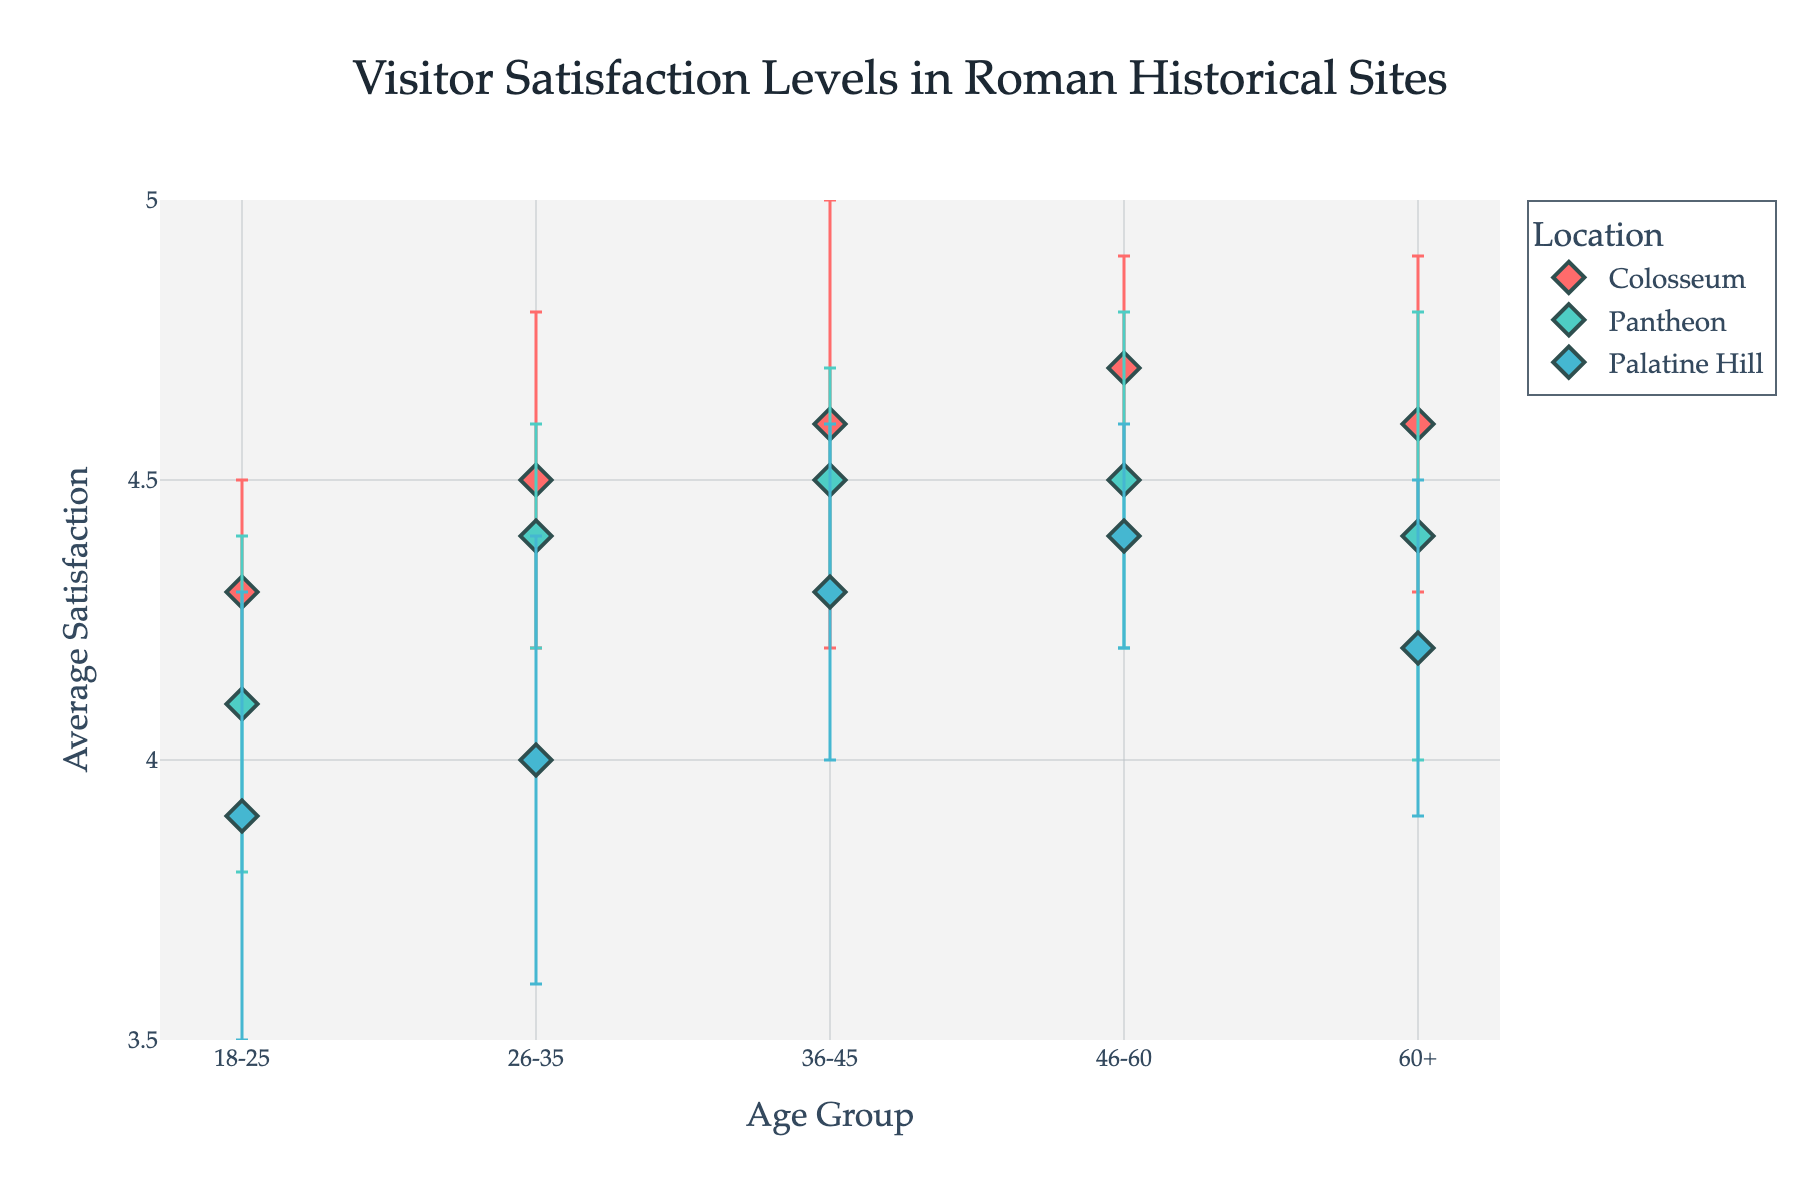What is the title of the plot? The title is displayed at the top of the plot, indicating the main subject of the visualized data. In this plot, the title is "Visitor Satisfaction Levels in Roman Historical Sites".
Answer: Visitor Satisfaction Levels in Roman Historical Sites What are the average satisfaction levels for the Colosseum among the 18-25 age group? Look for the marker representing the Colosseum for the 18-25 age group on the plot. The average satisfaction level is indicated by the position of the dot along the vertical axis.
Answer: 4.3 Which historical site has the highest average satisfaction level for the 46-60 age group? Compare the positions of the dots for the 46-60 age group across different historical sites. The highest position along the vertical axis indicates the highest average satisfaction level.
Answer: Colosseum What is the difference in average satisfaction level between the age groups 26-35 and 60+ for the Pantheon? Find the average satisfaction levels for the Pantheon in both the 26-35 and 60+ age groups. The values are 4.4 and 4.4 respectively. Subtract the smaller value from the larger one.
Answer: 0 Which age group shows the smallest error for the Palatine Hill site? Look for error bars attached to the dots representing the Palatine Hill site for different age groups. The smallest error is indicated by the shortest error bar.
Answer: 46-60 How does the average satisfaction level for the Colosseum compare between the age group 18-25 and 36-45? Check the average satisfaction values for the Colosseum in both age groups: 4.3 for 18-25 and 4.6 for 36-45. The 36-45 age group has a higher satisfaction level.
Answer: Higher for 36-45 What is the range of the y-axis in the plot? The y-axis range can be identified by examining the lowest and highest values marked on the y-axis scale. In this plot, it ranges from 3.5 to 5.
Answer: 3.5 to 5 If we consider the error bars, which location within the 36-45 age group has the largest possible satisfaction range? For the 36-45 age group, compare the lengths of the error bars for each location. The Colosseum has the most extensive error range of 0.4
Answer: Colosseum Where is the legend located, and what information does it provide? The legend, typically found on the right side of the plot, identifies different locations or categories represented by distinct markers and colors.
Answer: Right side, identifies locations 